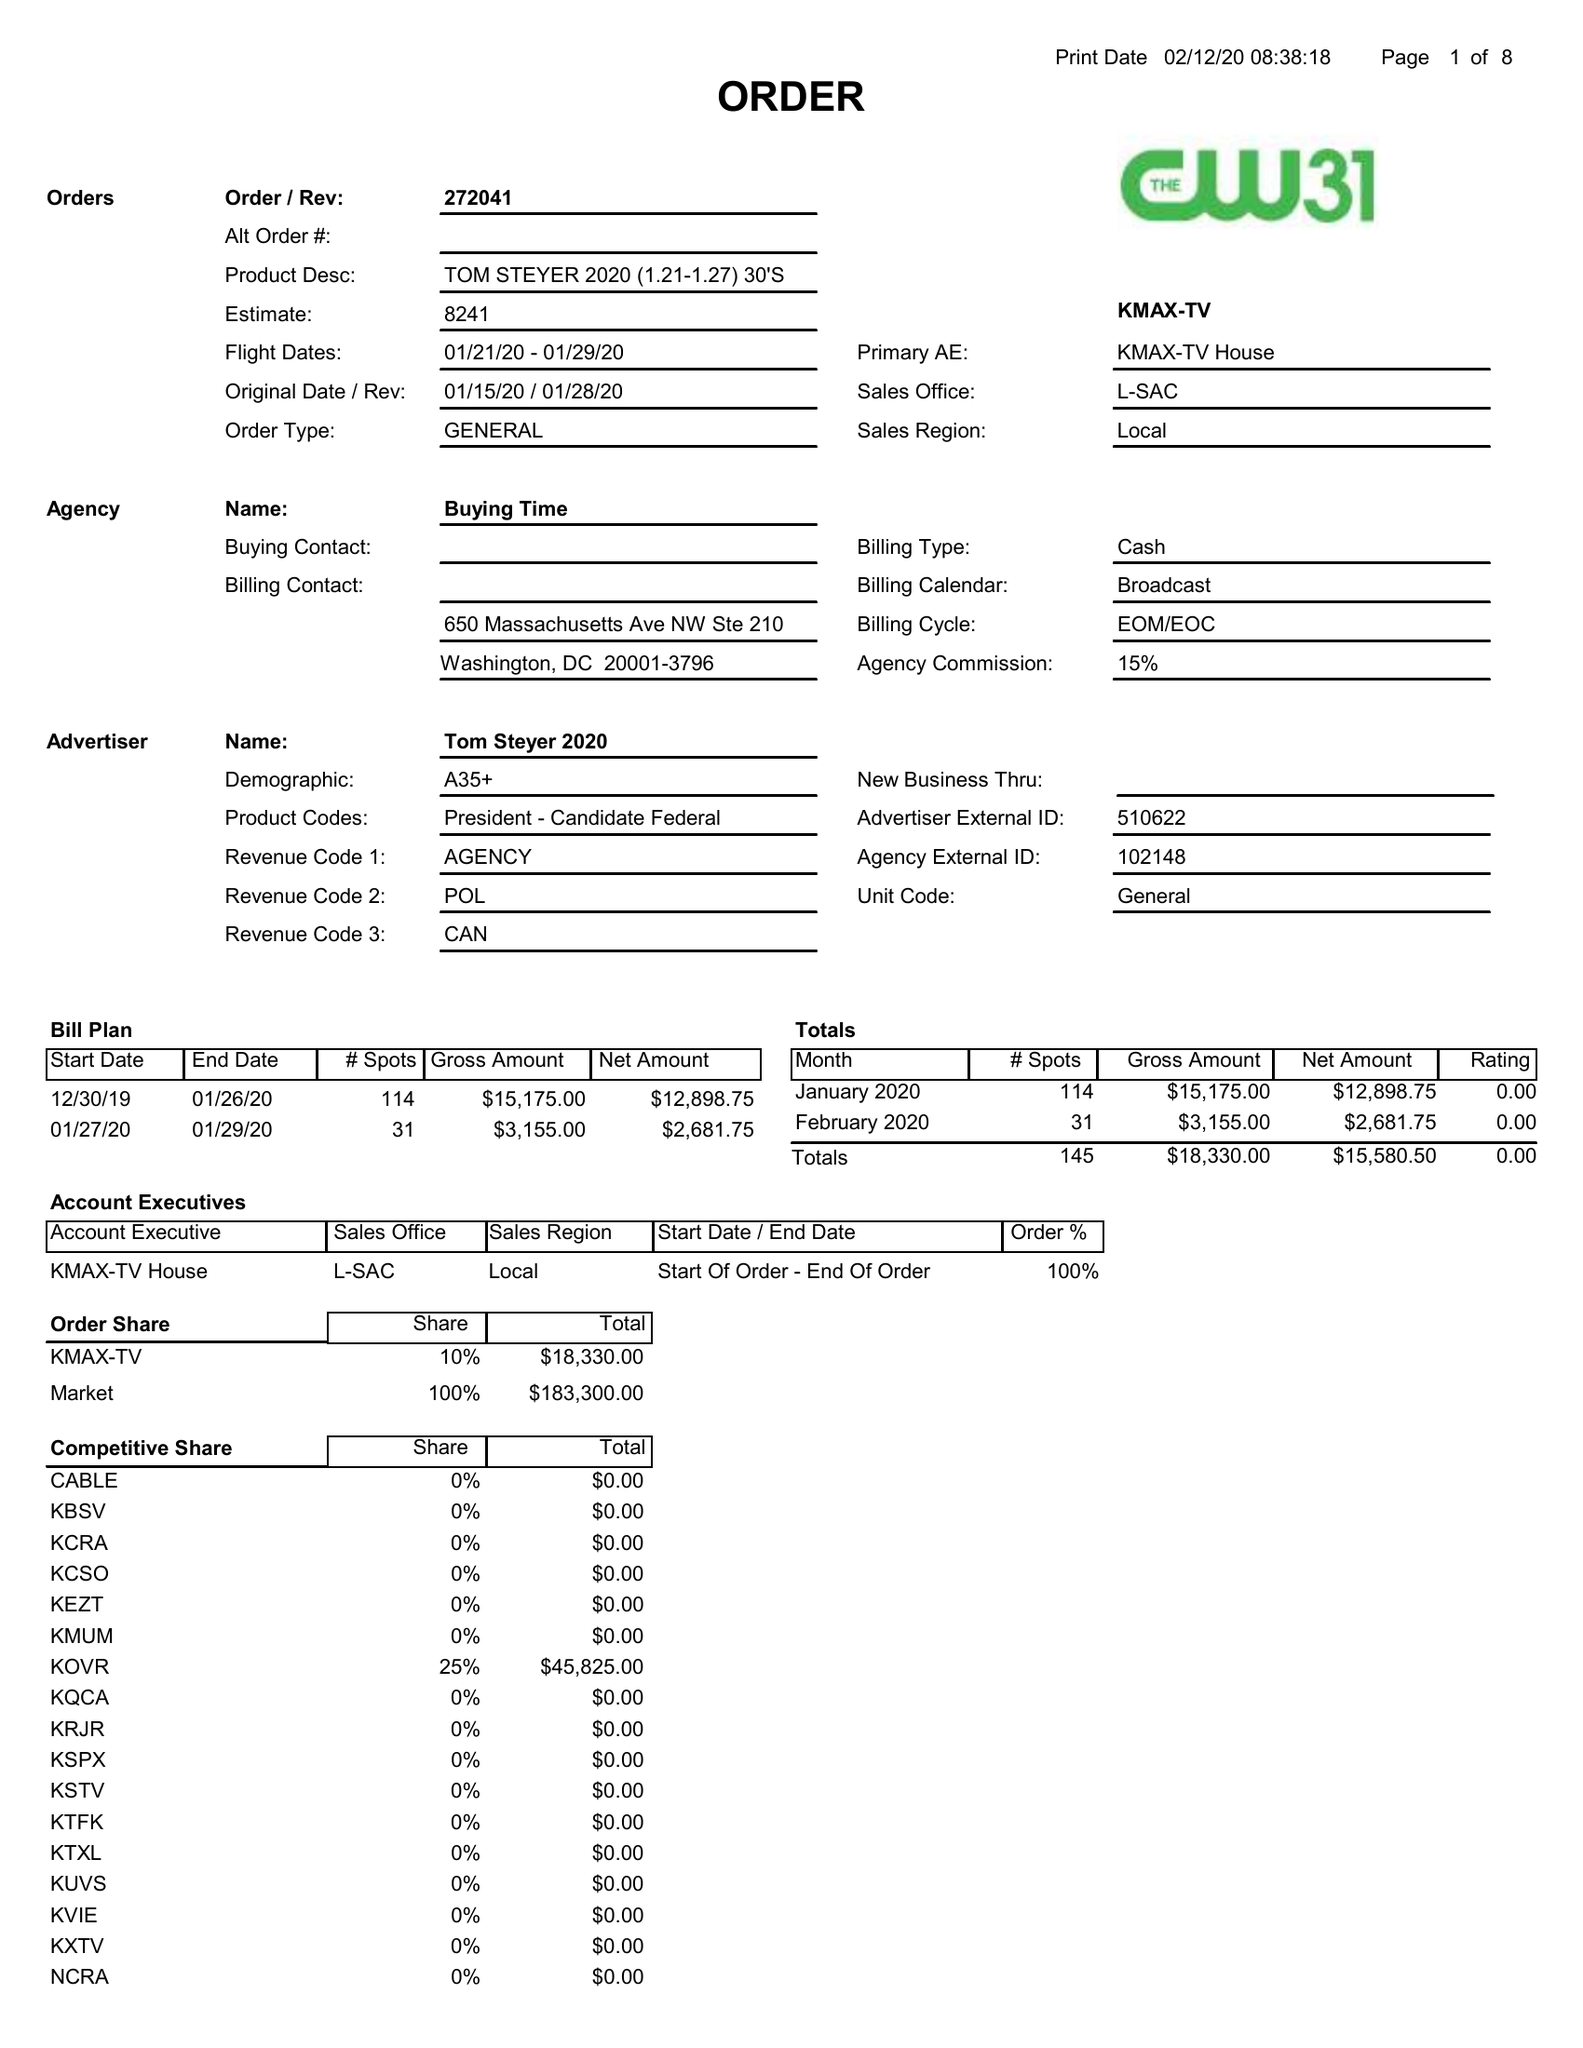What is the value for the flight_to?
Answer the question using a single word or phrase. 01/29/20 